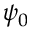<formula> <loc_0><loc_0><loc_500><loc_500>\psi _ { 0 }</formula> 